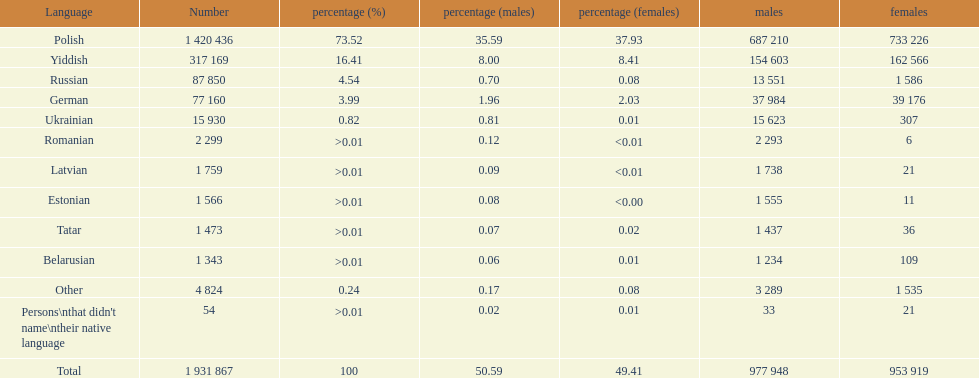What were all the languages? Polish, Yiddish, Russian, German, Ukrainian, Romanian, Latvian, Estonian, Tatar, Belarusian, Other, Persons\nthat didn't name\ntheir native language. For these, how many people spoke them? 1 420 436, 317 169, 87 850, 77 160, 15 930, 2 299, 1 759, 1 566, 1 473, 1 343, 4 824, 54. Of these, which is the largest number of speakers? 1 420 436. Which language corresponds to this number? Polish. 